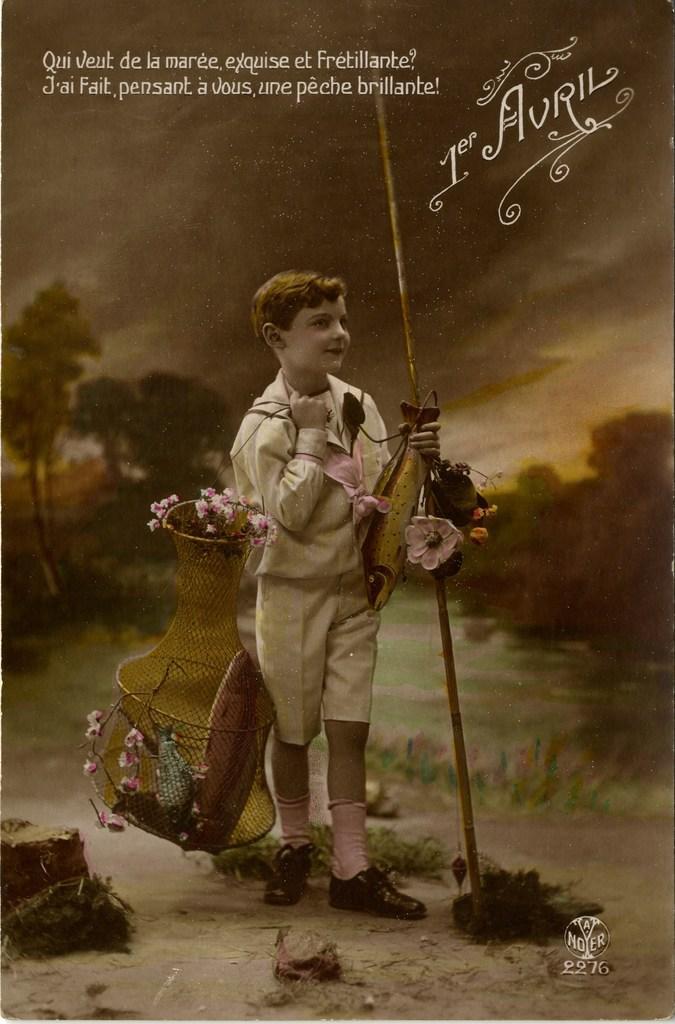Please provide a concise description of this image. The picture is a poster. At the top there are text. In the center of the picture there is a kid holding stick, cage, water bottle, flowers and other objects. In the foreground there is grass. In the background there are trees, plants and other objects. Sky is cloudy. 